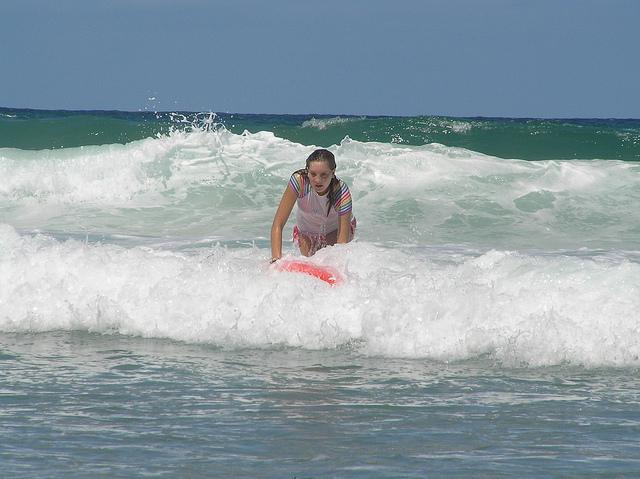How are the waves in the pic?
Keep it brief. Small. Is the girl submerged underwater?
Short answer required. No. Is she "riding" a wave?
Be succinct. Yes. Is this girl over the age of 18?
Keep it brief. No. What color is the surfboard?
Write a very short answer. Pink. 